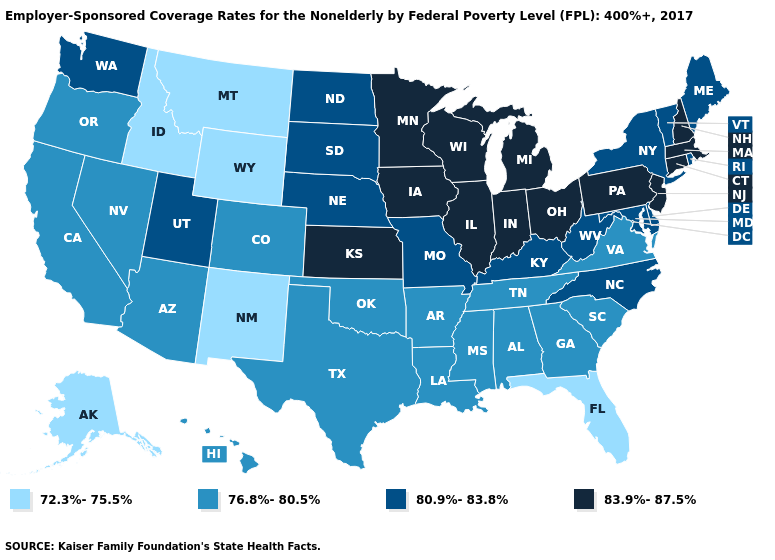What is the highest value in the USA?
Concise answer only. 83.9%-87.5%. What is the highest value in states that border South Dakota?
Answer briefly. 83.9%-87.5%. What is the lowest value in the South?
Give a very brief answer. 72.3%-75.5%. Name the states that have a value in the range 72.3%-75.5%?
Give a very brief answer. Alaska, Florida, Idaho, Montana, New Mexico, Wyoming. What is the highest value in the MidWest ?
Concise answer only. 83.9%-87.5%. Does Georgia have a lower value than Delaware?
Keep it brief. Yes. Does Mississippi have a higher value than New Mexico?
Write a very short answer. Yes. Name the states that have a value in the range 80.9%-83.8%?
Answer briefly. Delaware, Kentucky, Maine, Maryland, Missouri, Nebraska, New York, North Carolina, North Dakota, Rhode Island, South Dakota, Utah, Vermont, Washington, West Virginia. Among the states that border New Jersey , which have the highest value?
Short answer required. Pennsylvania. What is the value of Montana?
Short answer required. 72.3%-75.5%. Among the states that border Oregon , does Washington have the highest value?
Quick response, please. Yes. Does Idaho have the same value as South Dakota?
Answer briefly. No. Does Kansas have a higher value than Vermont?
Give a very brief answer. Yes. Name the states that have a value in the range 80.9%-83.8%?
Write a very short answer. Delaware, Kentucky, Maine, Maryland, Missouri, Nebraska, New York, North Carolina, North Dakota, Rhode Island, South Dakota, Utah, Vermont, Washington, West Virginia. Which states have the lowest value in the Northeast?
Give a very brief answer. Maine, New York, Rhode Island, Vermont. 